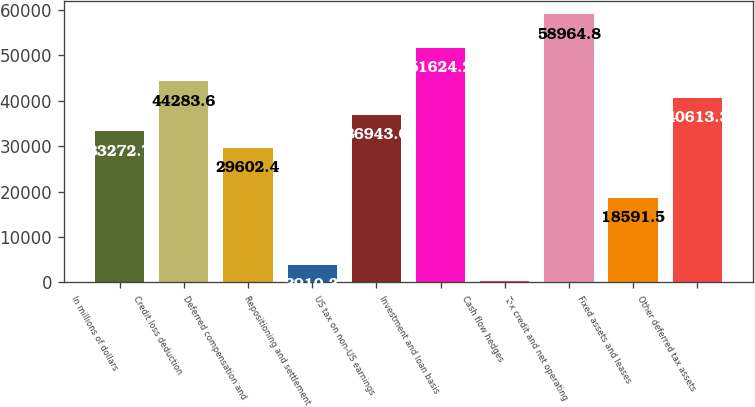Convert chart. <chart><loc_0><loc_0><loc_500><loc_500><bar_chart><fcel>In millions of dollars<fcel>Credit loss deduction<fcel>Deferred compensation and<fcel>Repositioning and settlement<fcel>US tax on non-US earnings<fcel>Investment and loan basis<fcel>Cash flow hedges<fcel>Tax credit and net operating<fcel>Fixed assets and leases<fcel>Other deferred tax assets<nl><fcel>33272.7<fcel>44283.6<fcel>29602.4<fcel>3910.3<fcel>36943<fcel>51624.2<fcel>240<fcel>58964.8<fcel>18591.5<fcel>40613.3<nl></chart> 